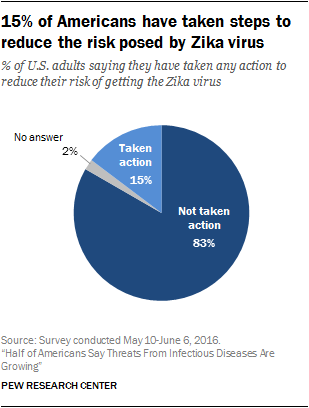Point out several critical features in this image. The sum of the smallest two segments is not equal to the largest segment. The smallest segment is gray in color. 